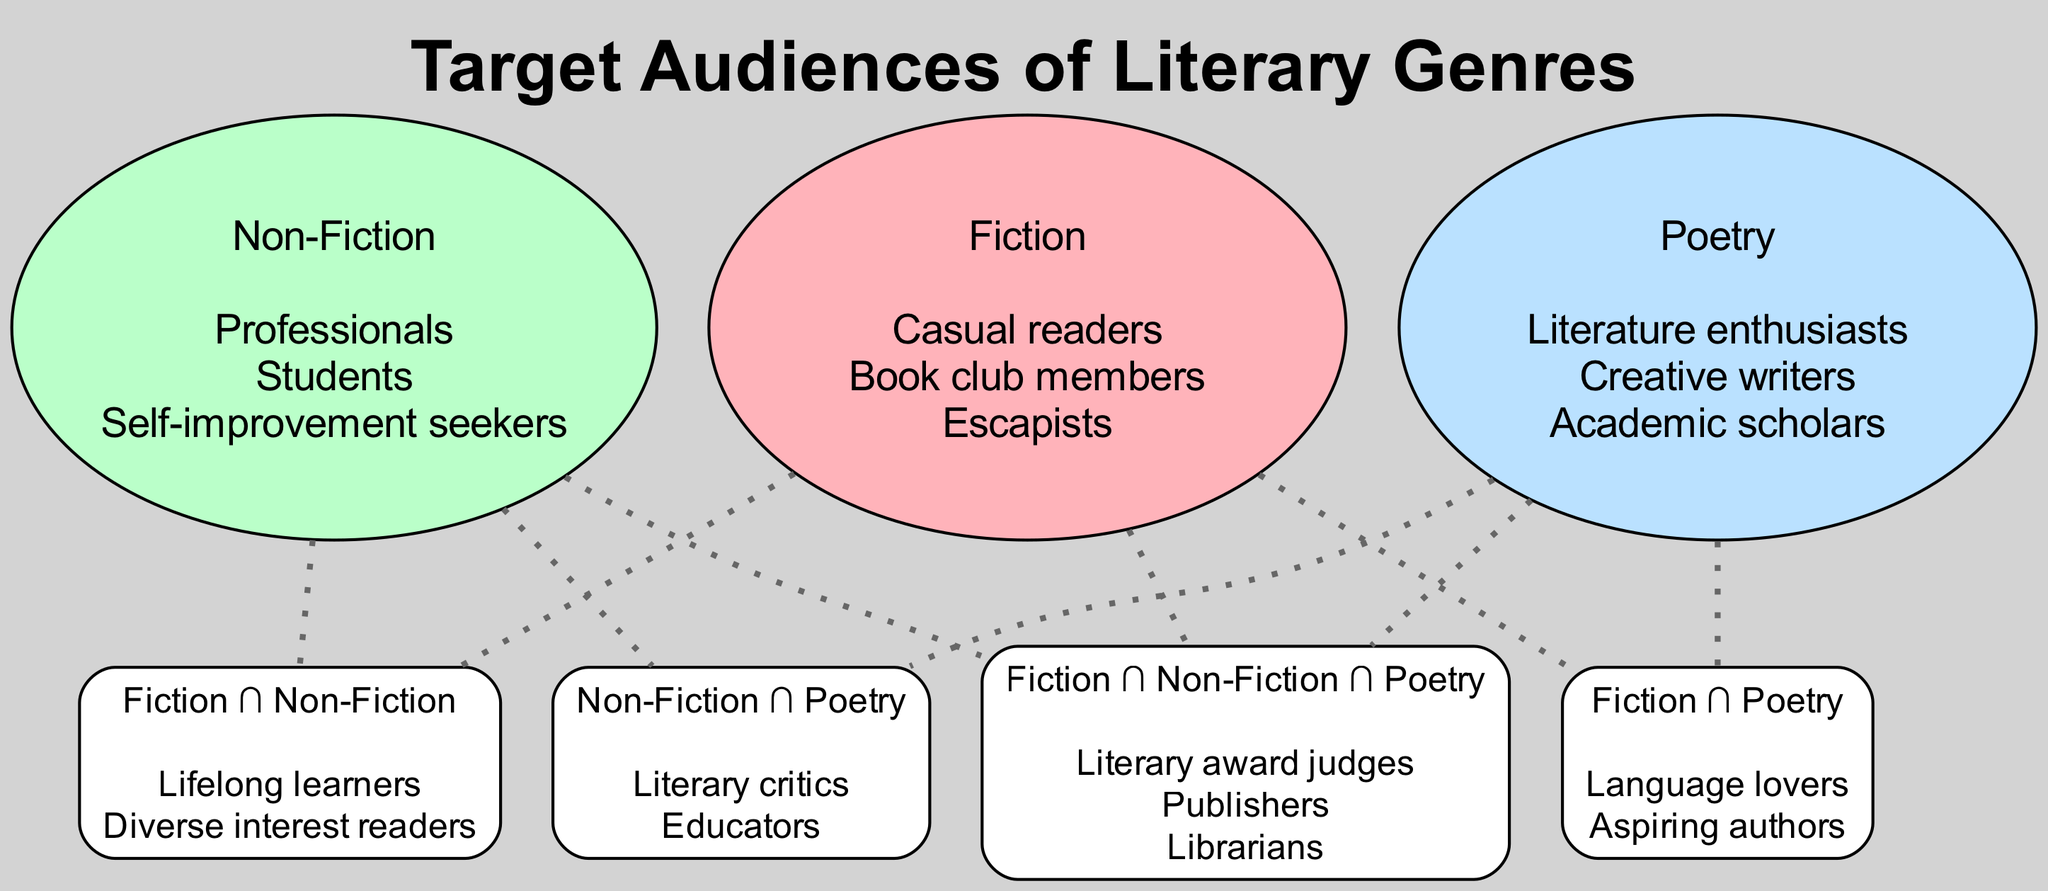What are the elements found in the Fiction set? The Fiction set includes: "Casual readers", "Book club members", and "Escapists". These elements are listed under the Fiction node in the diagram.
Answer: Casual readers, Book club members, Escapists How many elements are in the Non-Fiction set? The Non-Fiction set contains three elements: "Professionals", "Students", and "Self-improvement seekers". Thus, the count of elements is 3.
Answer: 3 Which audience is shared between Fiction and Poetry? The intersection of Fiction and Poetry includes "Language lovers" and "Aspiring authors". Therefore, these two elements represent the shared audience.
Answer: Language lovers, Aspiring authors Which set has the most diverse audience elements? Looking at the elements, Non-Fiction has a broader category including professionals from various fields and students pursuing knowledge, whereas Fiction targets casual and recreational reading interests. Based on the nature of the elements, Fiction appears to have a more diverse audience as it encompasses readers with varying reasons and contexts for reading.
Answer: Fiction How many total unique audience elements are there across all sets? To count the unique elements, we take the individual counts from each set, which gives a total of 3 (Fiction) + 3 (Non-Fiction) + 3 (Poetry) = 9 unique elements. Additionally, we consider those in the intersections (6 unique in 3 intersections summarized). Combining these gives 9 + 6 = 15 but noting overlaps correctly would lead to 15 overall dimensions that you can extract as audiences from exclusive set identities.
Answer: 15 Which audience is common to all three literary genres? The common audience among all three genres, as stated in the intersection involving all three sets, includes "Literary award judges", "Publishers", and "Librarians". These are the distinctive elements overlapping in all three domains.
Answer: Literary award judges, Publishers, Librarians What is the main audience characteristic in the Poetry set? The Poetry set mainly attracts "Literature enthusiasts", "Creative writers", and "Academic scholars". These characters highlight the audience’s deep appreciation for literature and its academic facets.
Answer: Literature enthusiasts, Creative writers, Academic scholars Which type of readers are included in the intersection of Fiction and Non-Fiction? The intersection between Fiction and Non-Fiction contains "Lifelong learners" and "Diverse interest readers". This points to readers who may engage with multiple genres based on their interests and desire for knowledge.
Answer: Lifelong learners, Diverse interest readers 